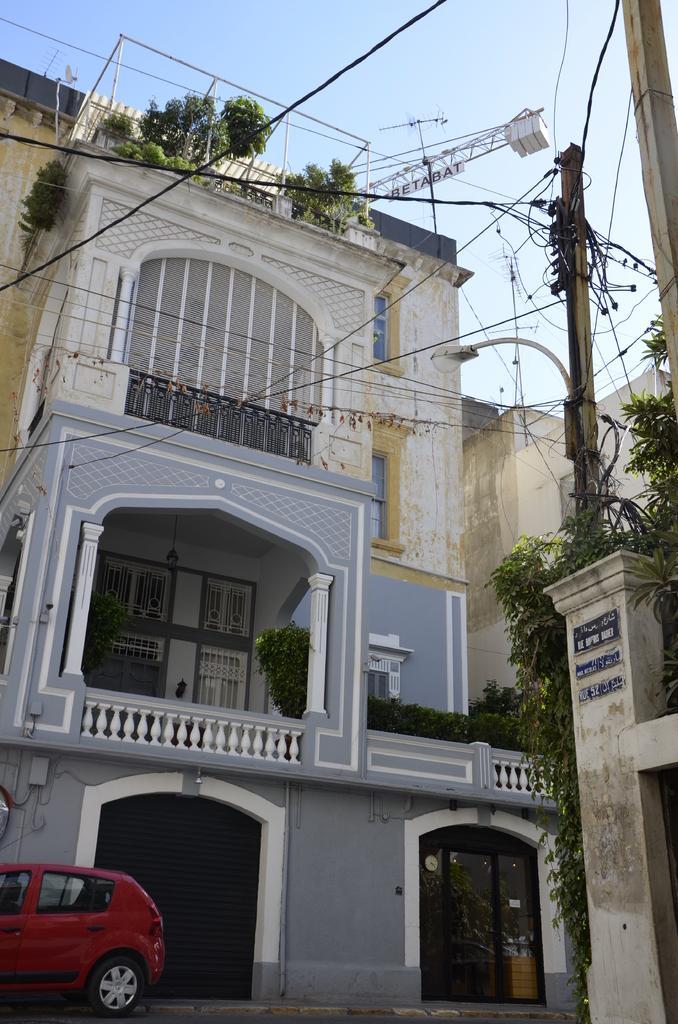How would you summarize this image in a sentence or two? In this picture we can see car on the road and we can see buildings, wires, railings, plants and rods. In the background of the image we can see the sky. On the right side of the image we can see poles, green leaves and boards on the wall. 